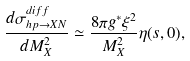Convert formula to latex. <formula><loc_0><loc_0><loc_500><loc_500>\frac { d \sigma ^ { d i f f } _ { h p \to X N } } { d M _ { X } ^ { 2 } } \simeq \frac { 8 \pi g ^ { * } \xi ^ { 2 } } { M _ { X } ^ { 2 } } \eta ( s , 0 ) ,</formula> 